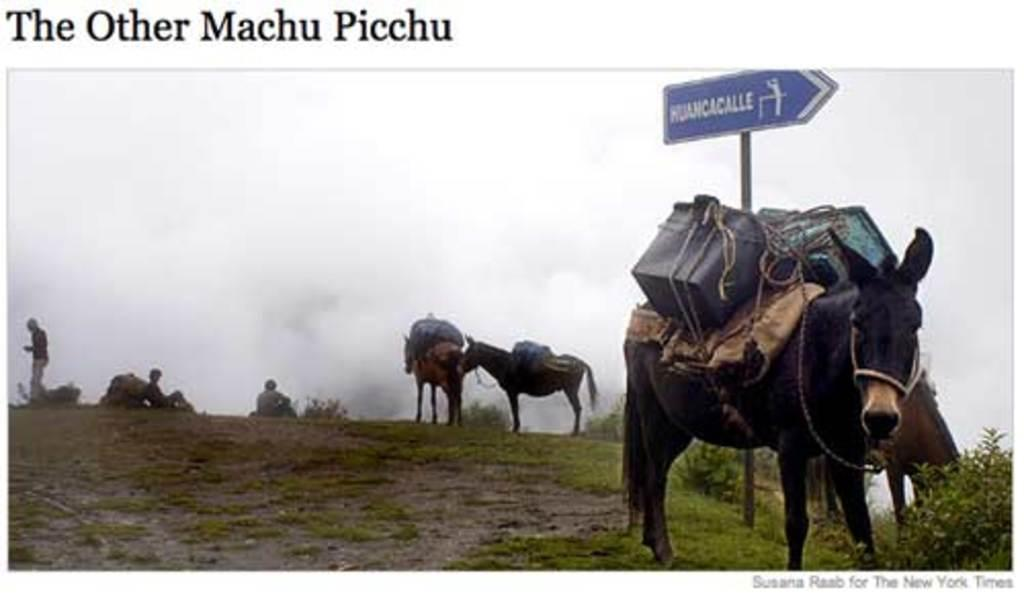What is located in the center of the image? There are animals in the center of the image. What can be seen on the left side of the image? There are people on the left side of the image. What type of vegetation is on the right side of the image? There is a plant on the right side of the image. What object is visible in the image that might be used for displaying information or messages? There is a board visible in the image. What type of cord or wire can be seen connecting the animals to the people in the image? There is no cord or wire connecting the animals to the people in the image; the animals and people are separate entities. Is there a bike visible in the image? There is no bike present in the image. 